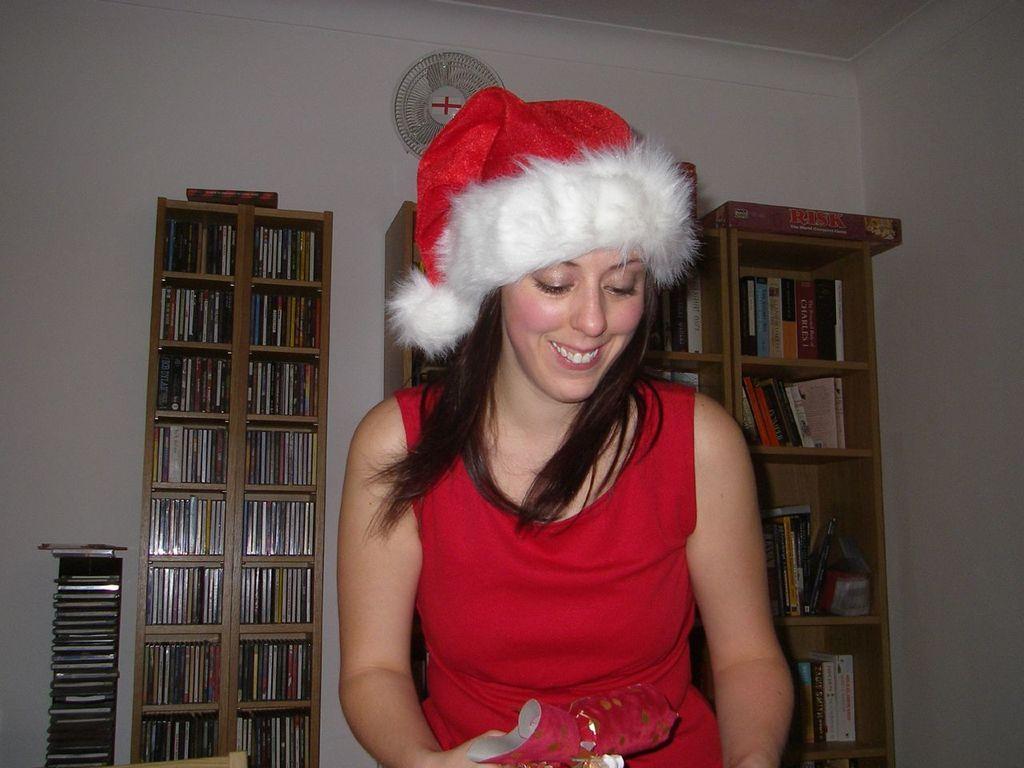Describe this image in one or two sentences. This picture is clicked inside. In the center there is a woman wearing red color dress, smiling seems to be sitting and holding some object. In the background we can see the wall, table fan and the cabinets containing many number of books and there are some objects placed on the ground. In the background we can see the wall and the roof. 